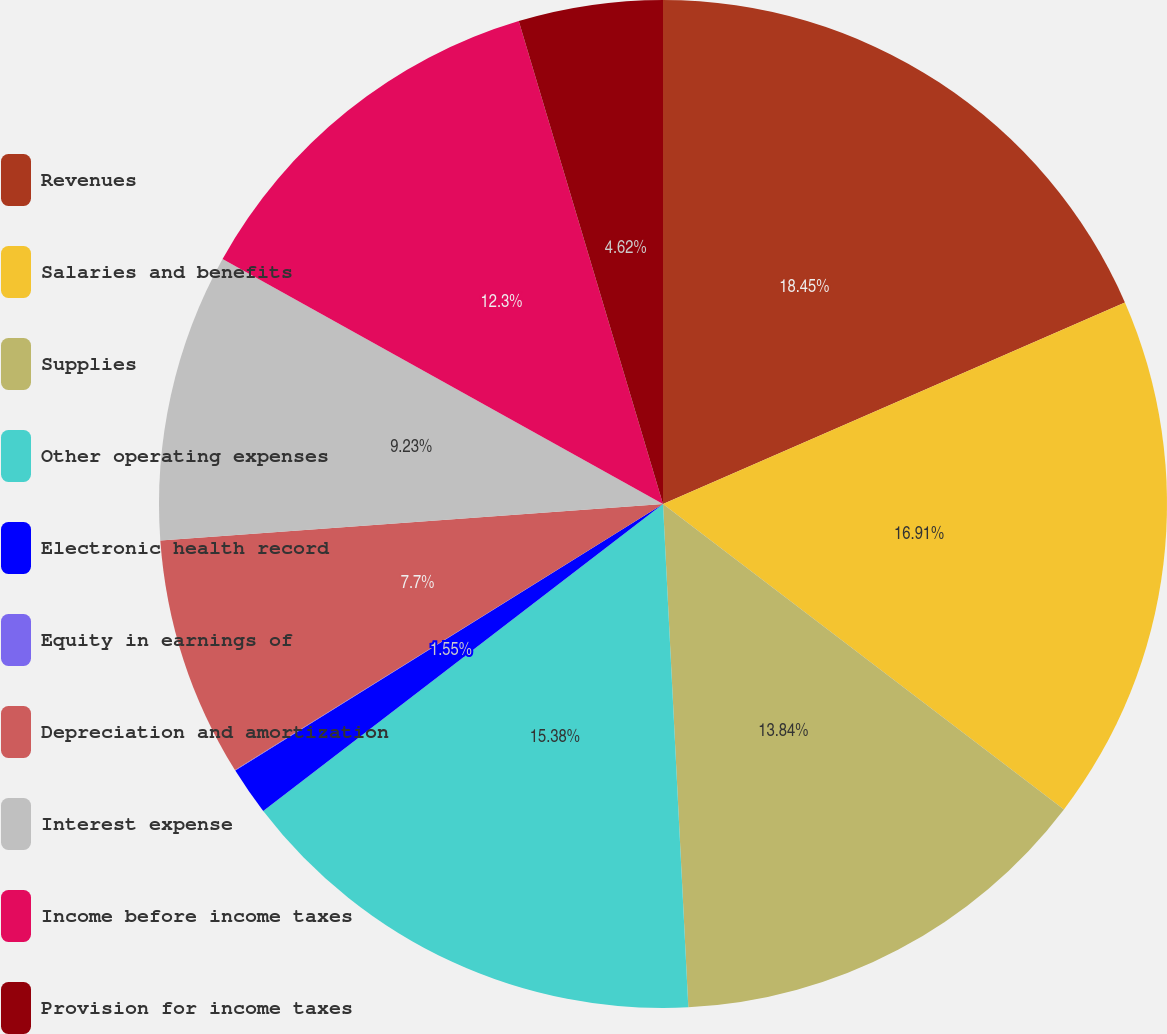Convert chart to OTSL. <chart><loc_0><loc_0><loc_500><loc_500><pie_chart><fcel>Revenues<fcel>Salaries and benefits<fcel>Supplies<fcel>Other operating expenses<fcel>Electronic health record<fcel>Equity in earnings of<fcel>Depreciation and amortization<fcel>Interest expense<fcel>Income before income taxes<fcel>Provision for income taxes<nl><fcel>18.45%<fcel>16.91%<fcel>13.84%<fcel>15.38%<fcel>1.55%<fcel>0.02%<fcel>7.7%<fcel>9.23%<fcel>12.3%<fcel>4.62%<nl></chart> 